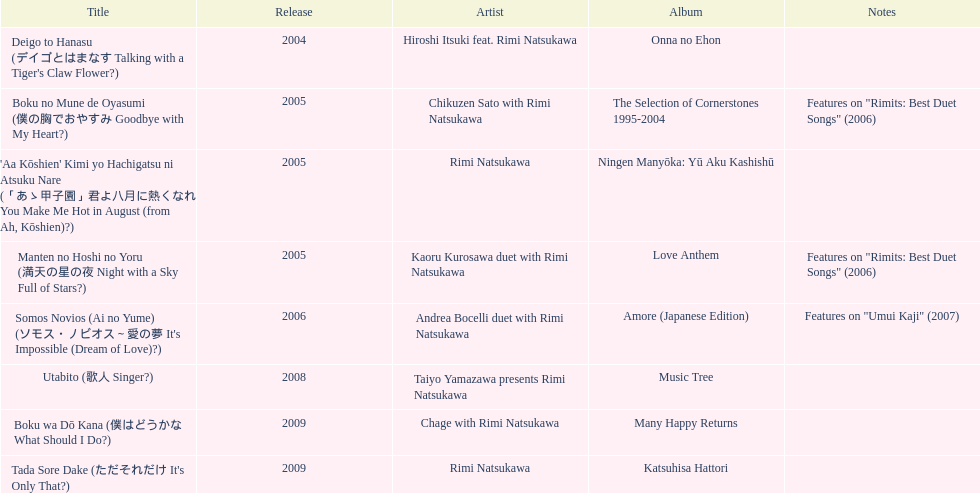What was the album released immediately before the one that had boku wa do kana on it? Music Tree. 